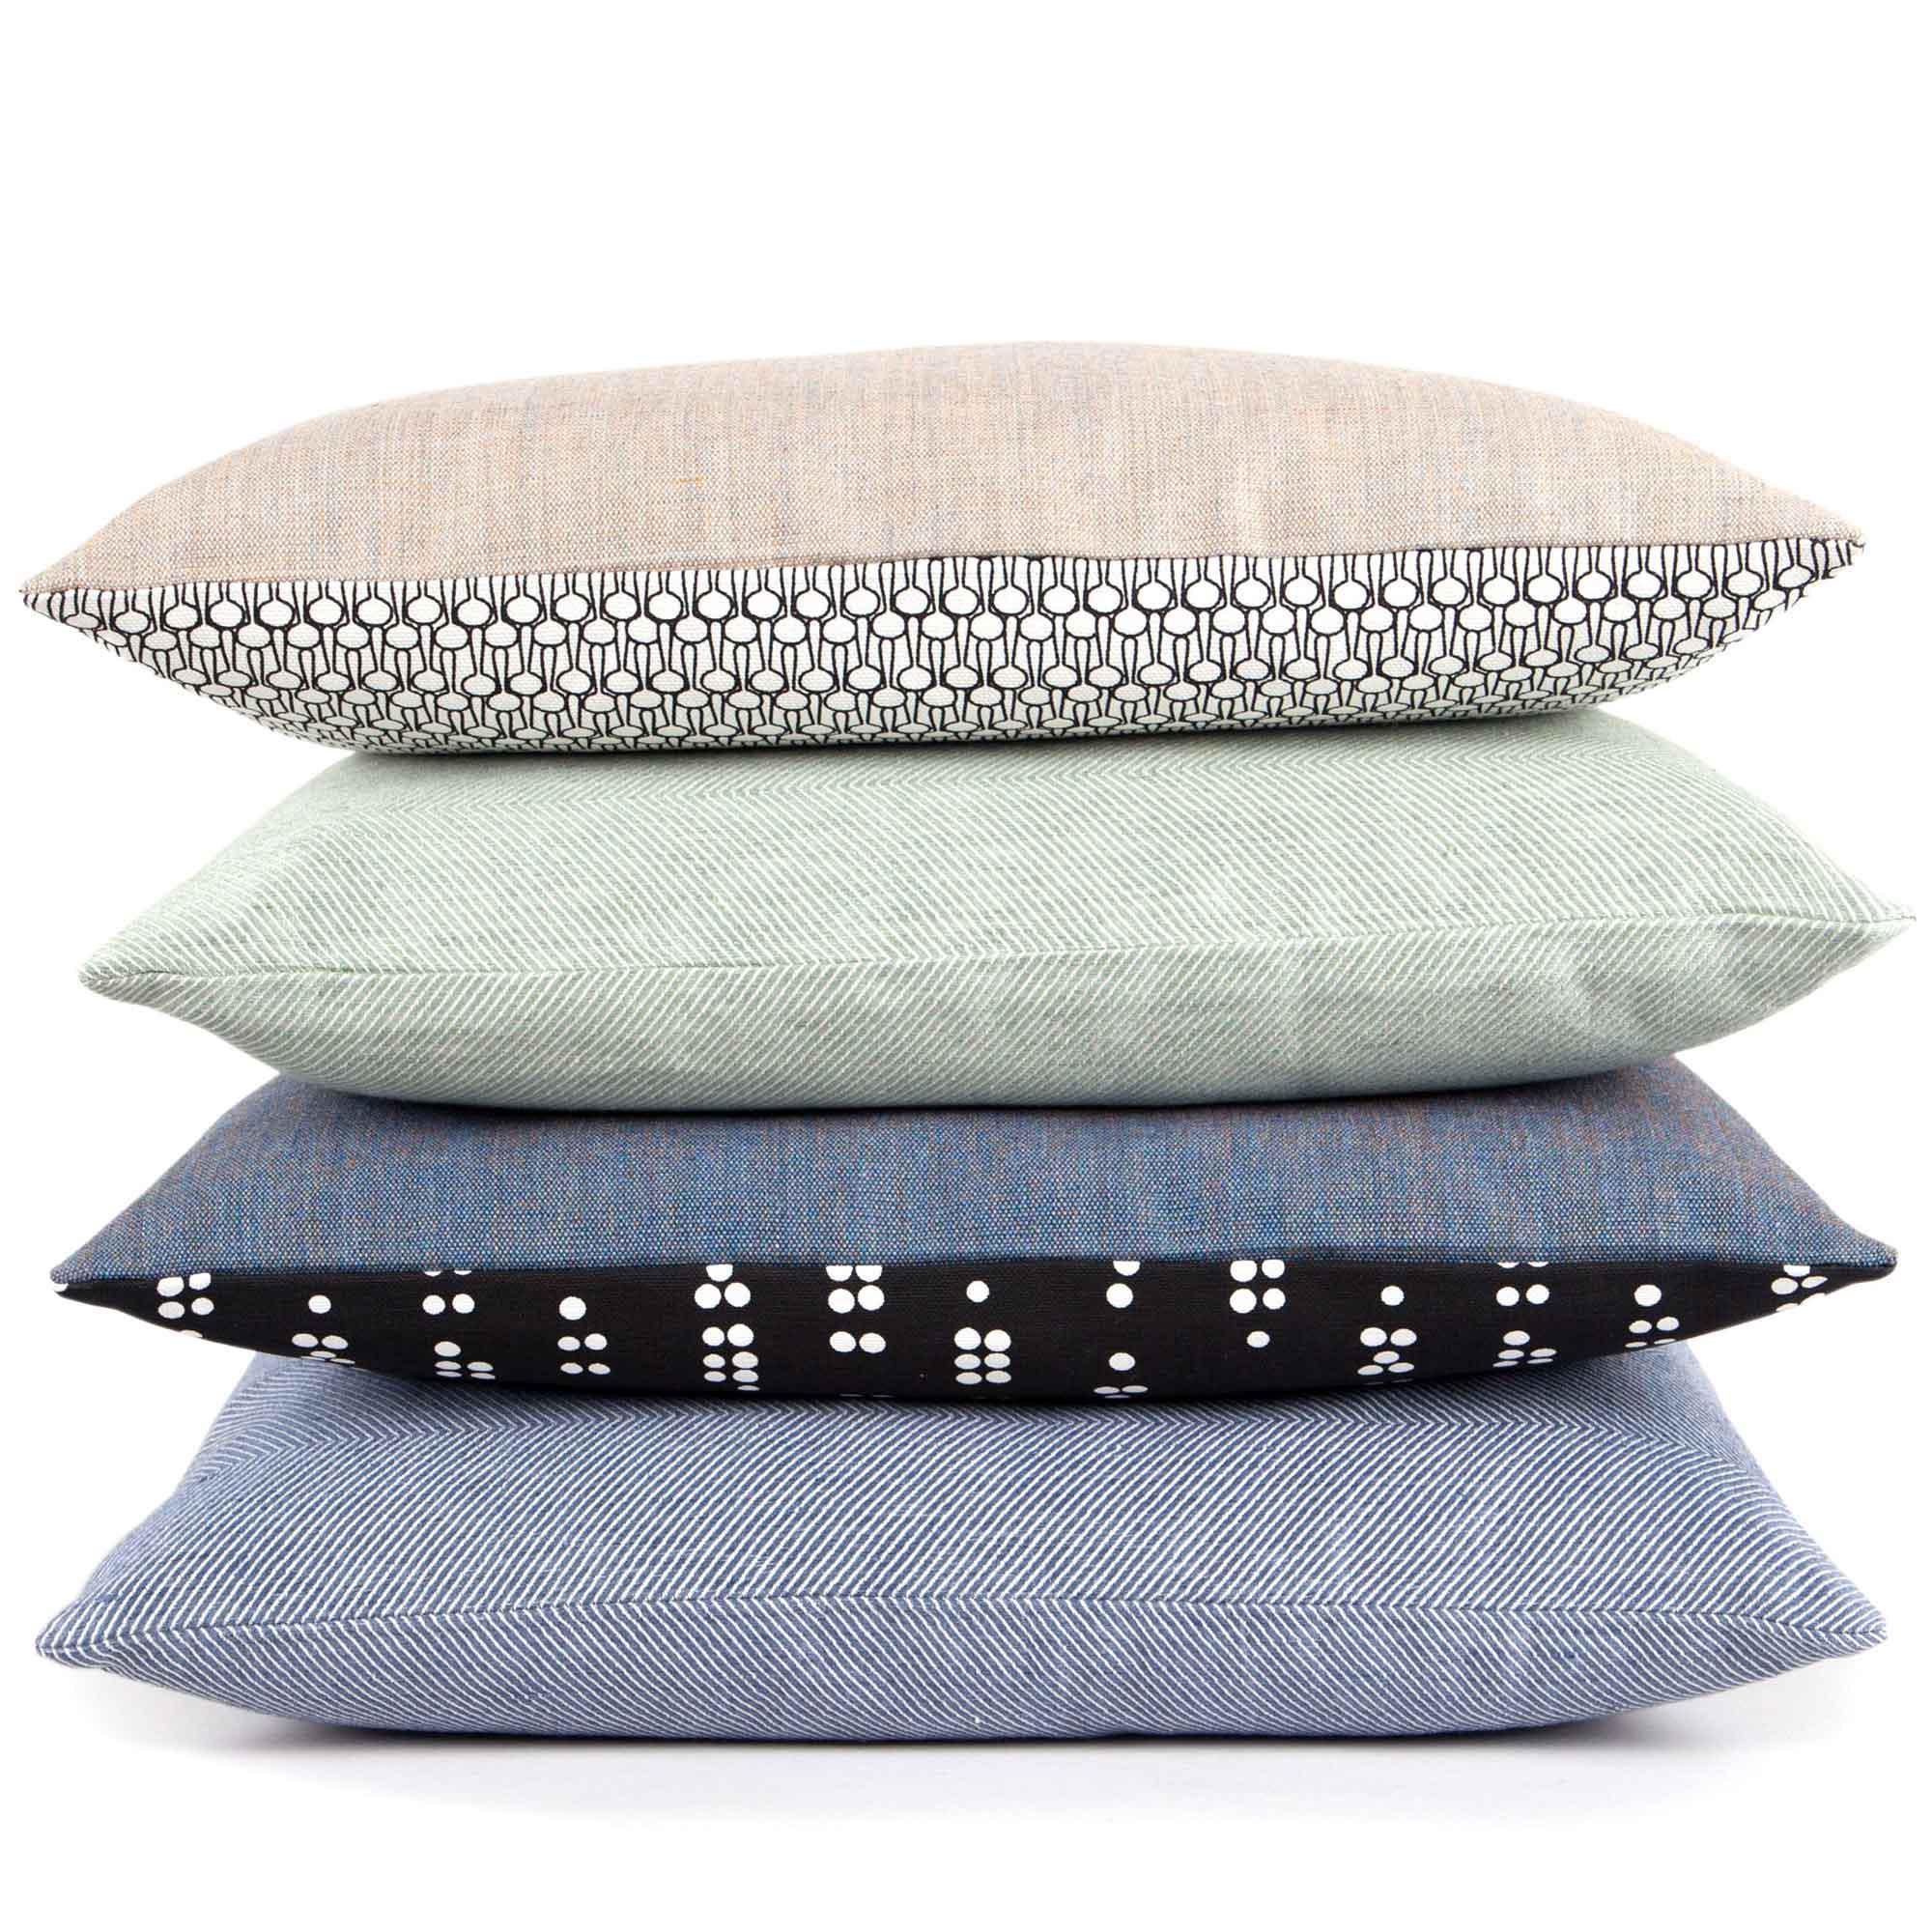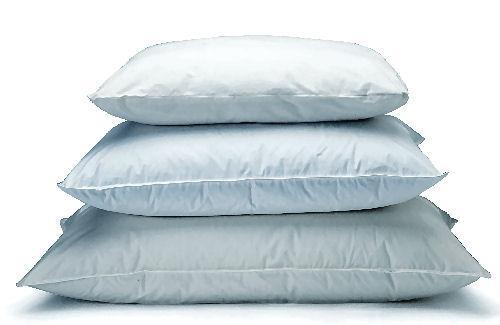The first image is the image on the left, the second image is the image on the right. For the images shown, is this caption "There are at most 7 pillows in the pair of images." true? Answer yes or no. Yes. The first image is the image on the left, the second image is the image on the right. For the images displayed, is the sentence "A pillow stack includes a pinkish-violet pillow the second from the bottom." factually correct? Answer yes or no. No. 